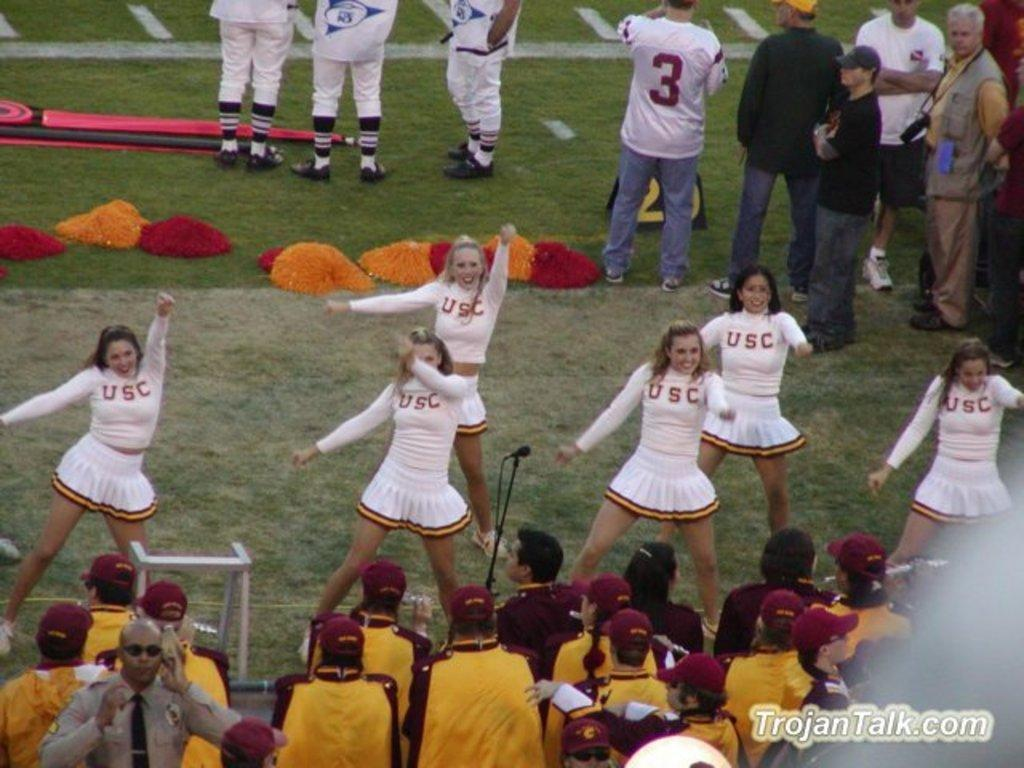<image>
Give a short and clear explanation of the subsequent image. USC Cheerleaders dancing and cheering at a football game. photo taken by trojantalk.com. 